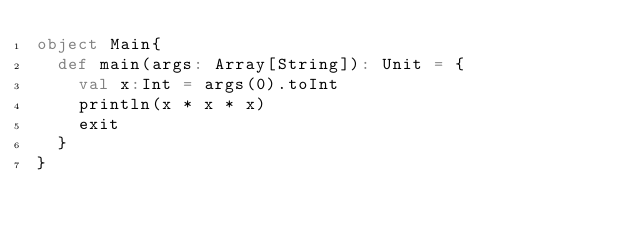<code> <loc_0><loc_0><loc_500><loc_500><_Scala_>object Main{
  def main(args: Array[String]): Unit = {
    val x:Int = args(0).toInt
    println(x * x * x)
    exit
  }
}</code> 